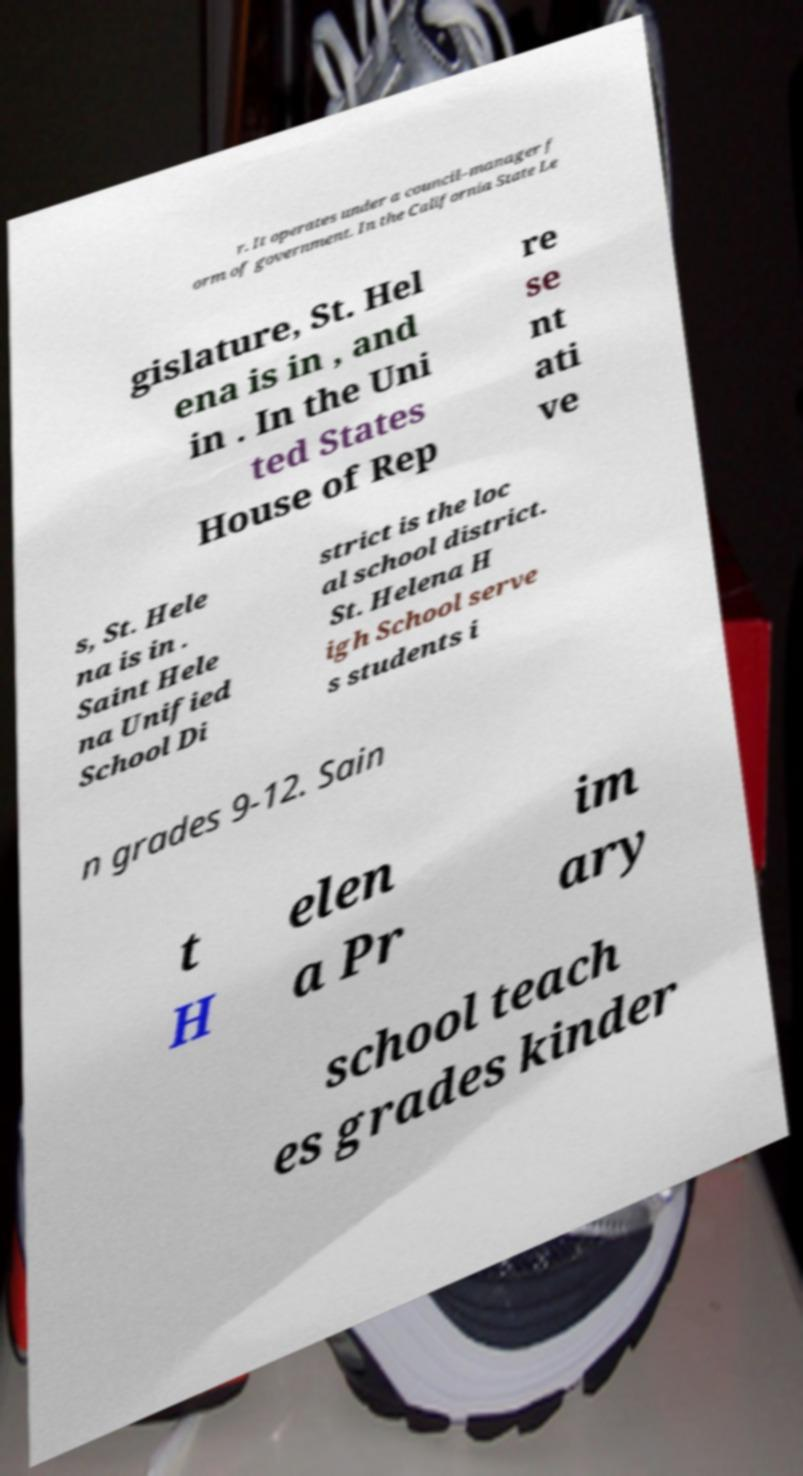There's text embedded in this image that I need extracted. Can you transcribe it verbatim? r. It operates under a council–manager f orm of government. In the California State Le gislature, St. Hel ena is in , and in . In the Uni ted States House of Rep re se nt ati ve s, St. Hele na is in . Saint Hele na Unified School Di strict is the loc al school district. St. Helena H igh School serve s students i n grades 9-12. Sain t H elen a Pr im ary school teach es grades kinder 